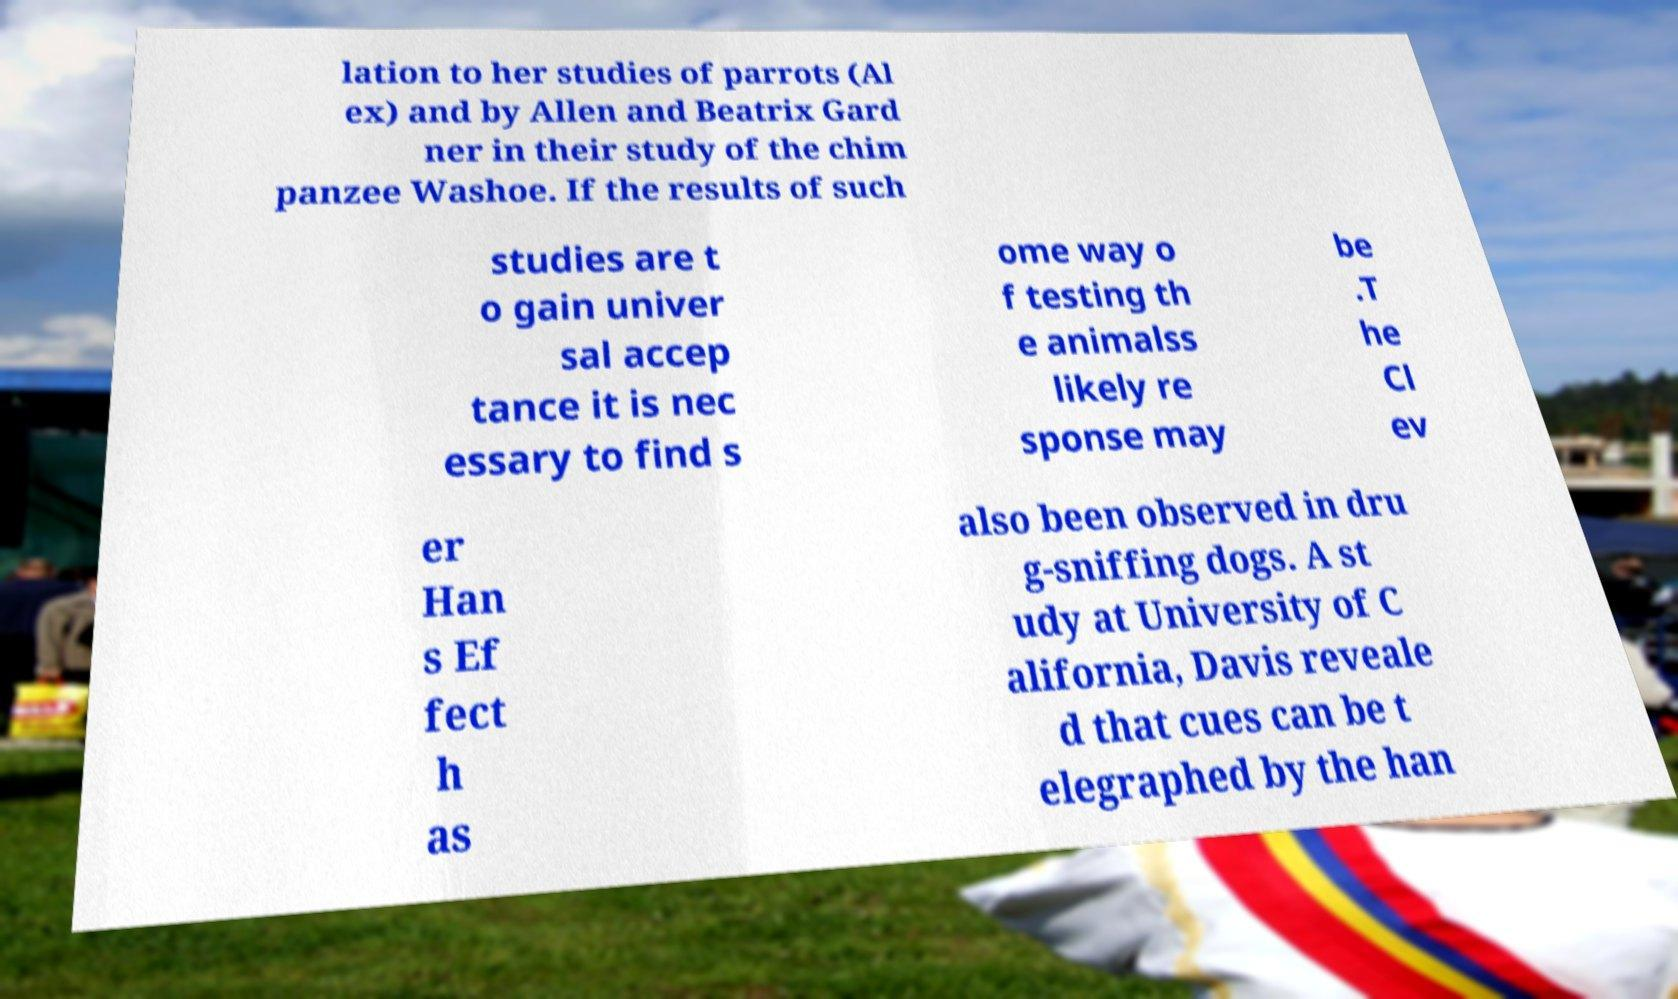What messages or text are displayed in this image? I need them in a readable, typed format. lation to her studies of parrots (Al ex) and by Allen and Beatrix Gard ner in their study of the chim panzee Washoe. If the results of such studies are t o gain univer sal accep tance it is nec essary to find s ome way o f testing th e animalss likely re sponse may be .T he Cl ev er Han s Ef fect h as also been observed in dru g-sniffing dogs. A st udy at University of C alifornia, Davis reveale d that cues can be t elegraphed by the han 